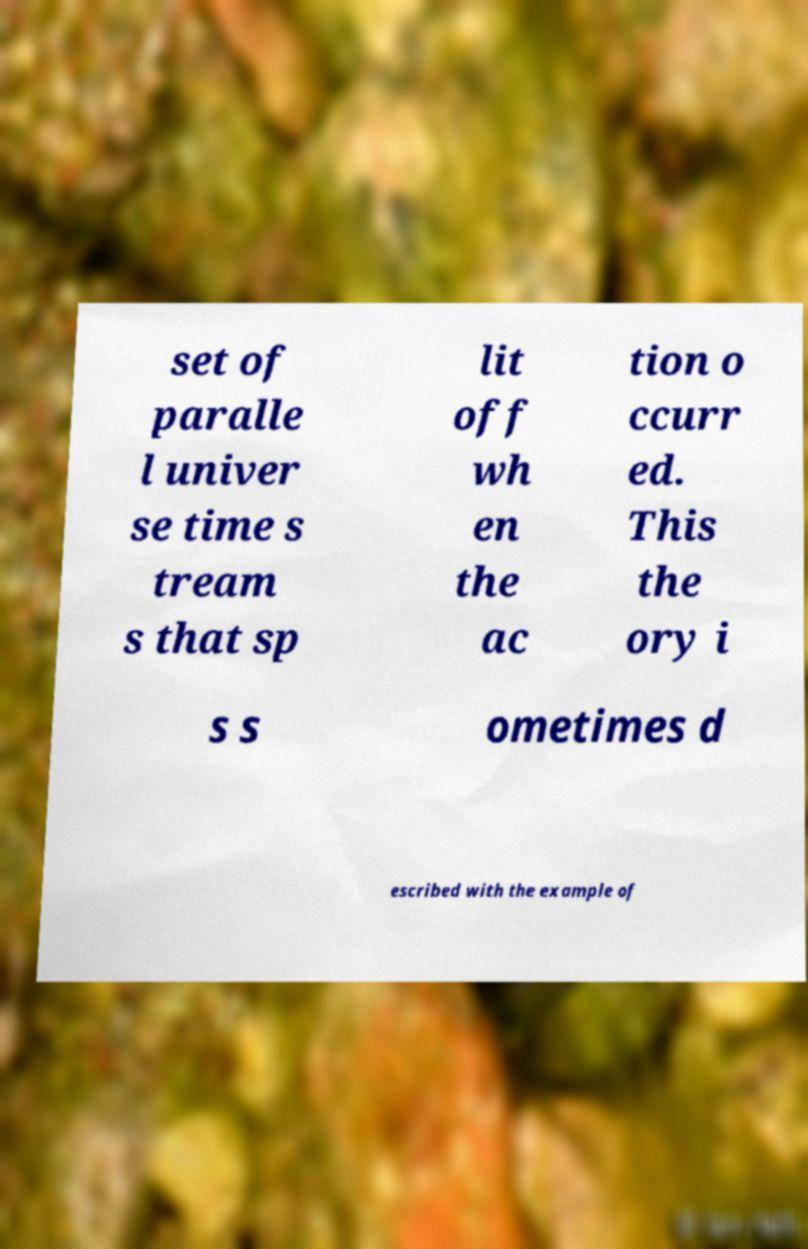Can you read and provide the text displayed in the image?This photo seems to have some interesting text. Can you extract and type it out for me? set of paralle l univer se time s tream s that sp lit off wh en the ac tion o ccurr ed. This the ory i s s ometimes d escribed with the example of 